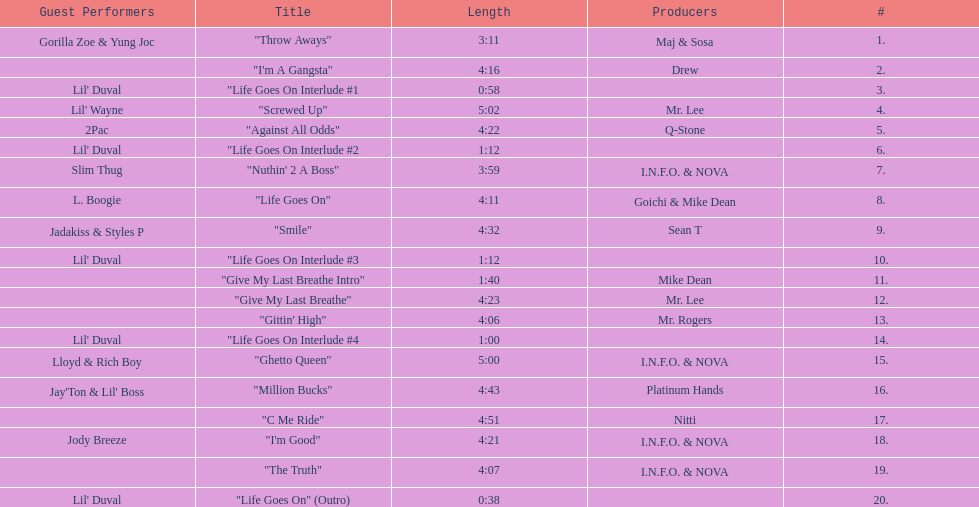What's the overall count of tracks present on the album? 20. 